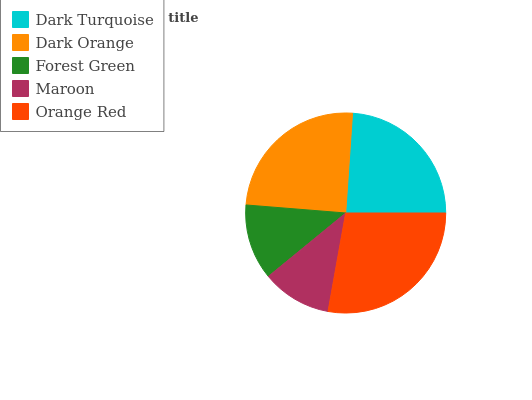Is Maroon the minimum?
Answer yes or no. Yes. Is Orange Red the maximum?
Answer yes or no. Yes. Is Dark Orange the minimum?
Answer yes or no. No. Is Dark Orange the maximum?
Answer yes or no. No. Is Dark Orange greater than Dark Turquoise?
Answer yes or no. Yes. Is Dark Turquoise less than Dark Orange?
Answer yes or no. Yes. Is Dark Turquoise greater than Dark Orange?
Answer yes or no. No. Is Dark Orange less than Dark Turquoise?
Answer yes or no. No. Is Dark Turquoise the high median?
Answer yes or no. Yes. Is Dark Turquoise the low median?
Answer yes or no. Yes. Is Forest Green the high median?
Answer yes or no. No. Is Forest Green the low median?
Answer yes or no. No. 